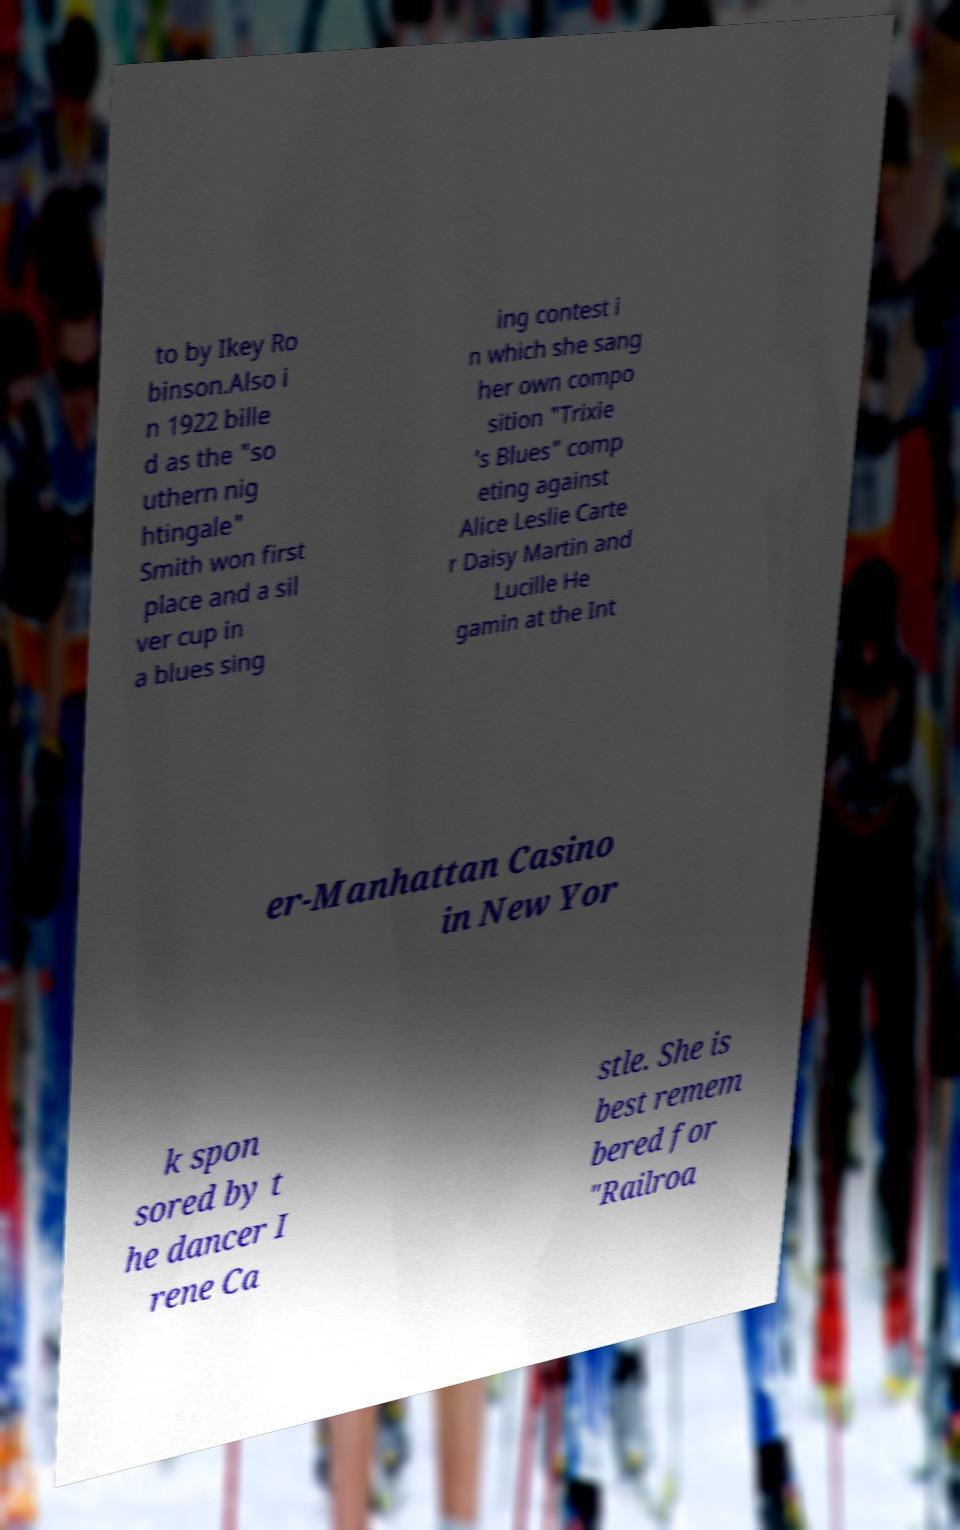Can you read and provide the text displayed in the image?This photo seems to have some interesting text. Can you extract and type it out for me? to by Ikey Ro binson.Also i n 1922 bille d as the "so uthern nig htingale" Smith won first place and a sil ver cup in a blues sing ing contest i n which she sang her own compo sition "Trixie 's Blues" comp eting against Alice Leslie Carte r Daisy Martin and Lucille He gamin at the Int er-Manhattan Casino in New Yor k spon sored by t he dancer I rene Ca stle. She is best remem bered for "Railroa 